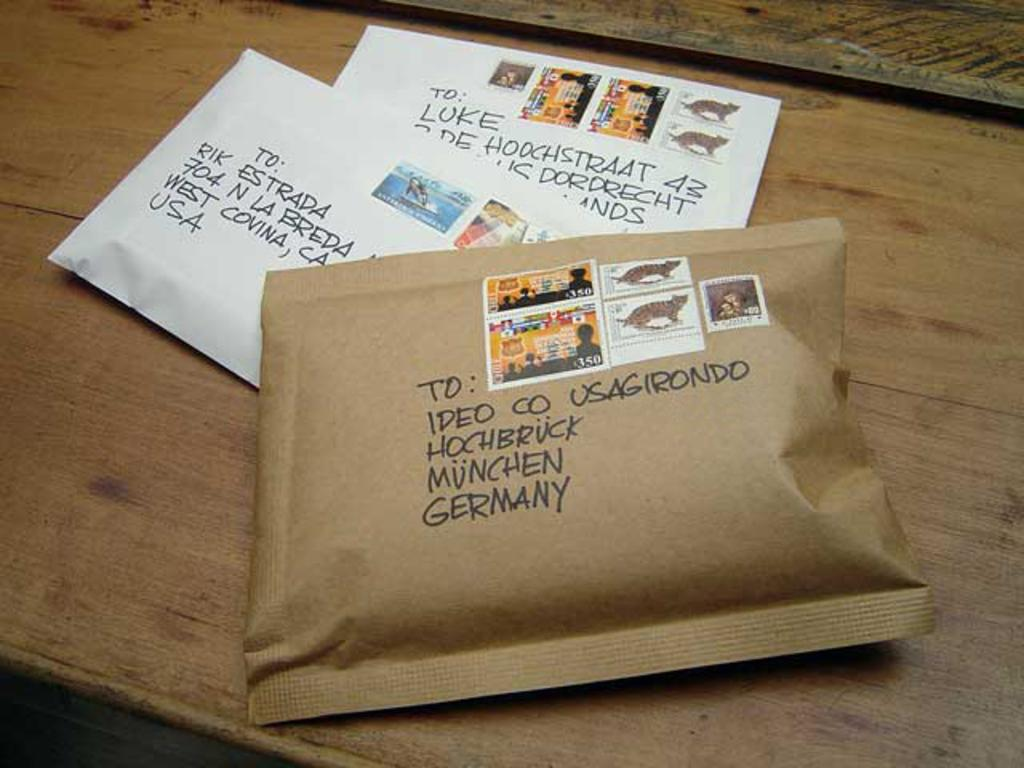Provide a one-sentence caption for the provided image. Two white and one brown large padded envelopes, the brown one in front labeled Munchen Germany. 